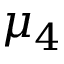<formula> <loc_0><loc_0><loc_500><loc_500>\mu _ { 4 }</formula> 